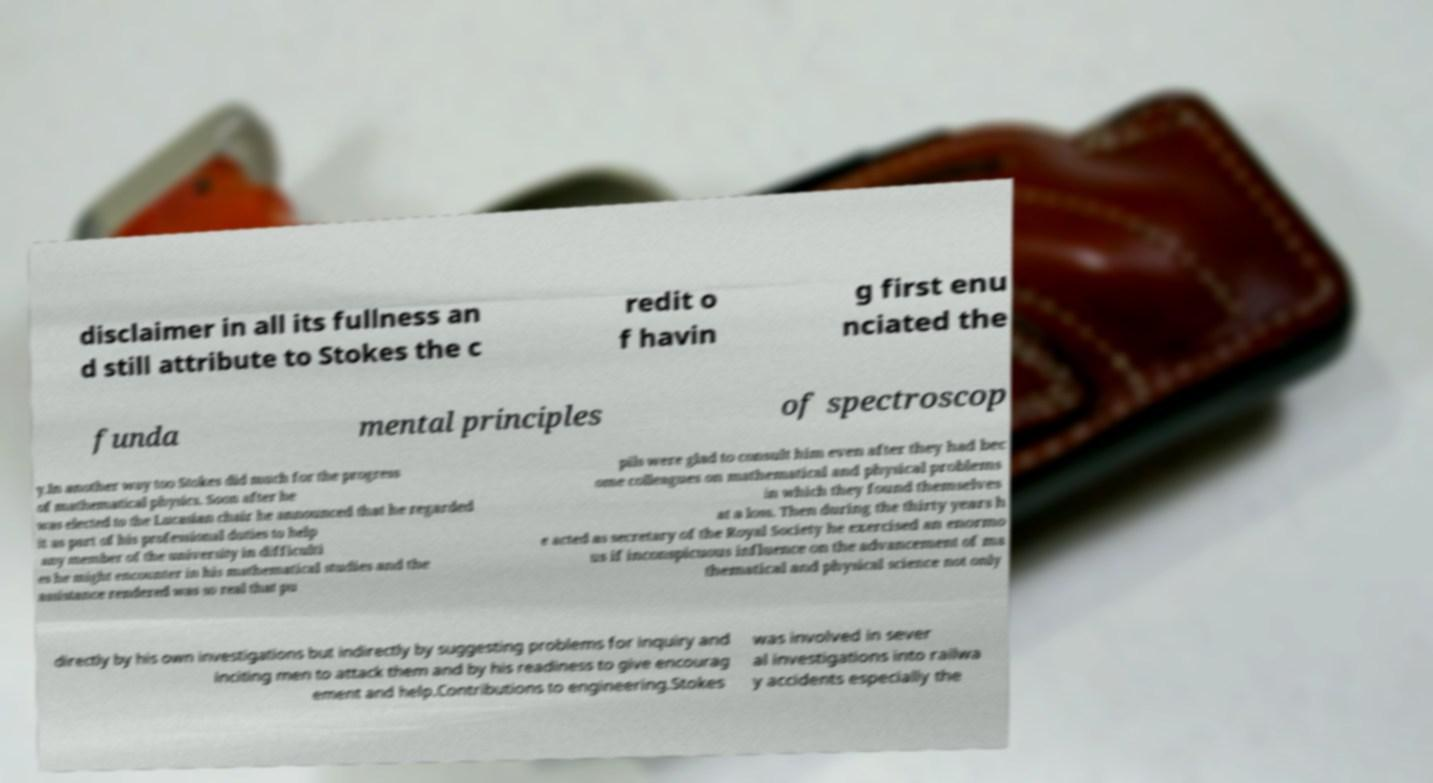What messages or text are displayed in this image? I need them in a readable, typed format. disclaimer in all its fullness an d still attribute to Stokes the c redit o f havin g first enu nciated the funda mental principles of spectroscop y.In another way too Stokes did much for the progress of mathematical physics. Soon after he was elected to the Lucasian chair he announced that he regarded it as part of his professional duties to help any member of the university in difficulti es he might encounter in his mathematical studies and the assistance rendered was so real that pu pils were glad to consult him even after they had bec ome colleagues on mathematical and physical problems in which they found themselves at a loss. Then during the thirty years h e acted as secretary of the Royal Society he exercised an enormo us if inconspicuous influence on the advancement of ma thematical and physical science not only directly by his own investigations but indirectly by suggesting problems for inquiry and inciting men to attack them and by his readiness to give encourag ement and help.Contributions to engineering.Stokes was involved in sever al investigations into railwa y accidents especially the 